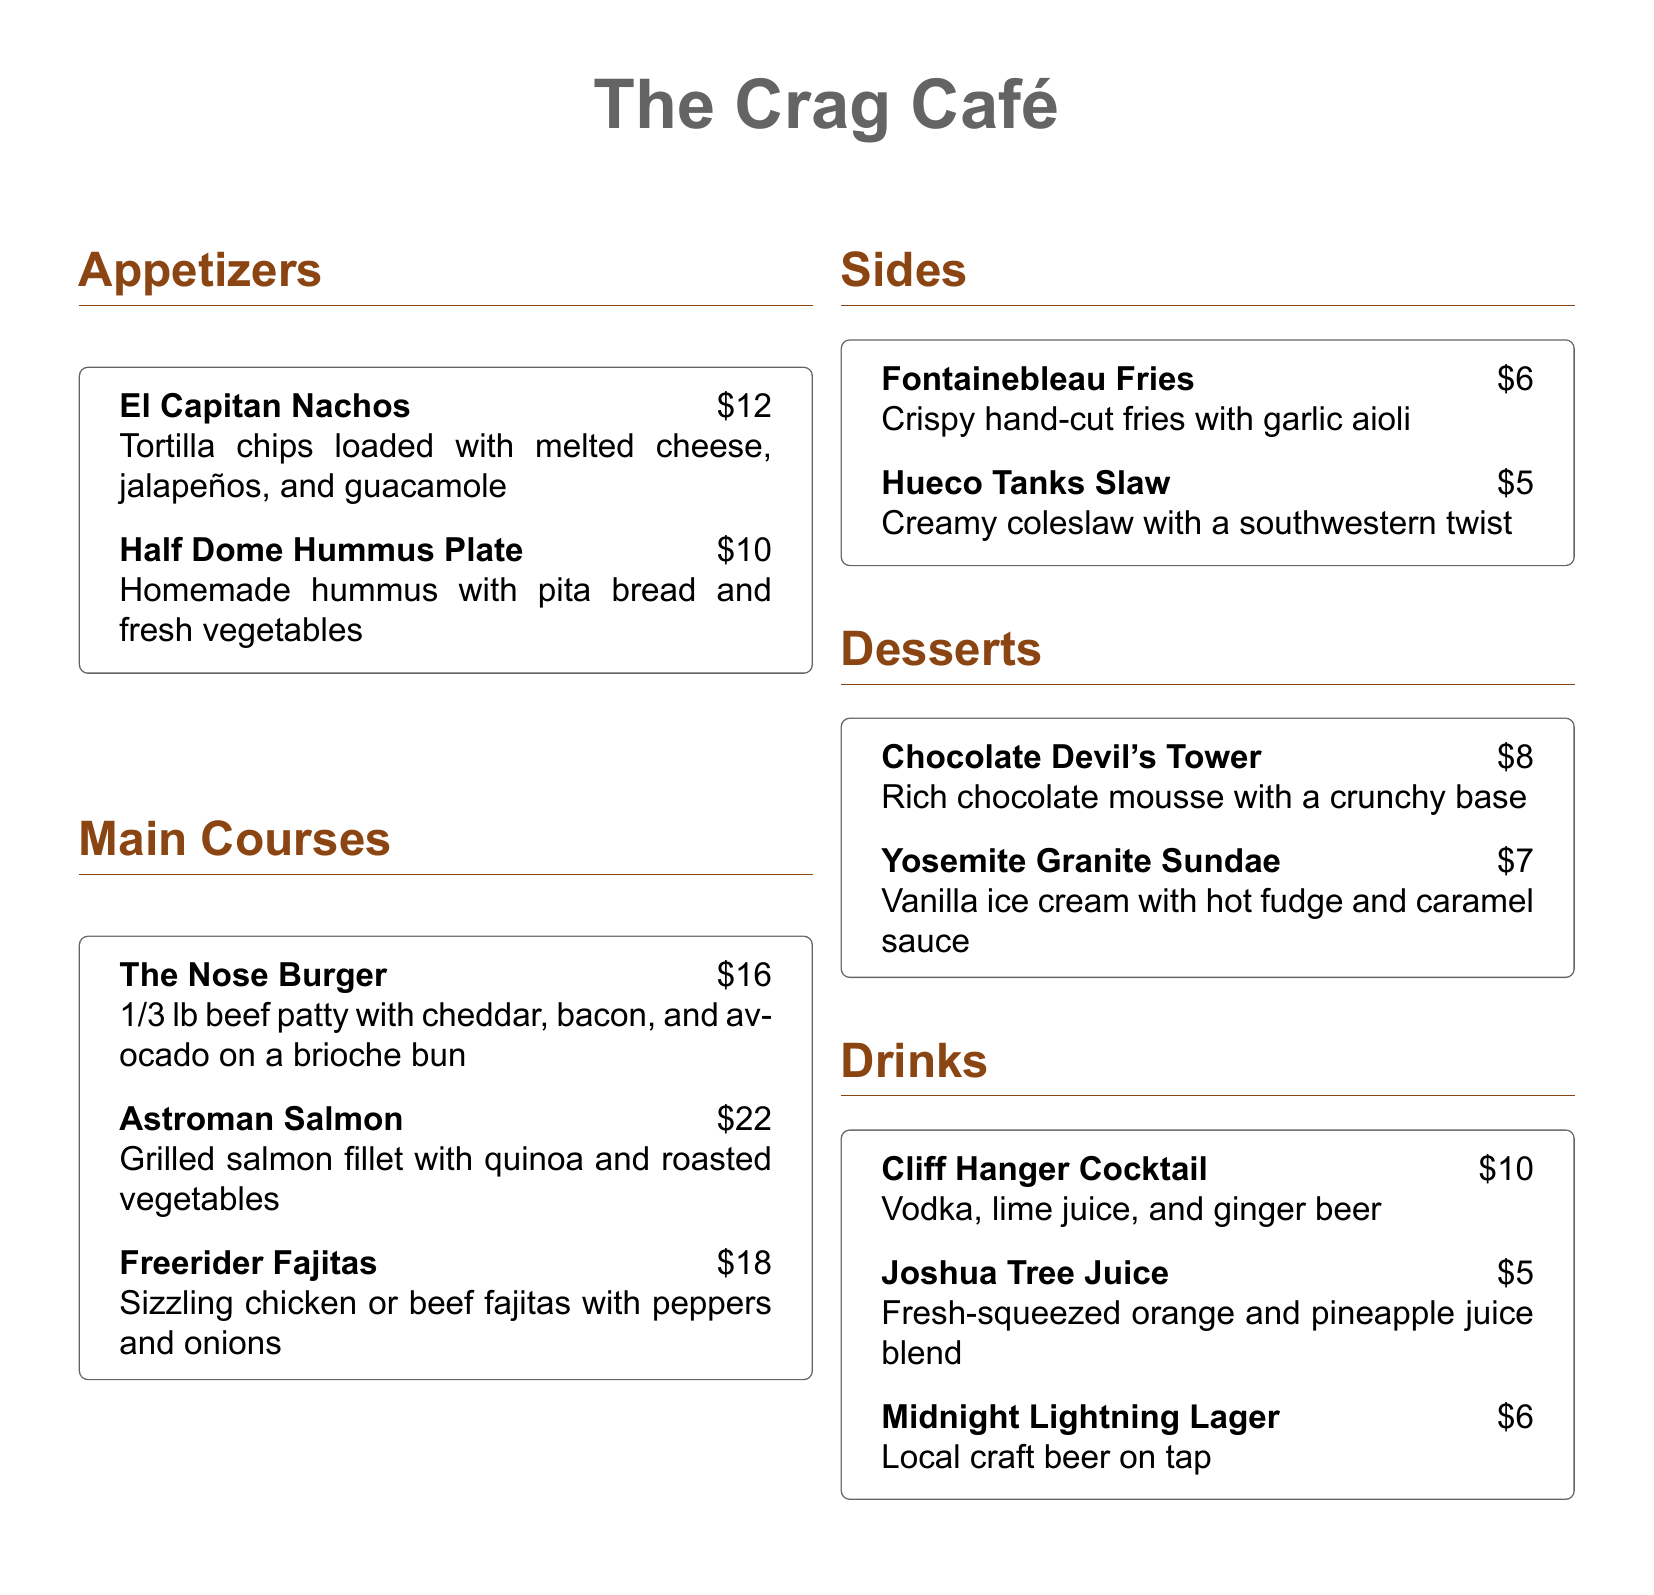What is the most expensive main course? The most expensive main course is listed in the "Main Courses" section of the document, which is "Astroman Salmon" for $22.
Answer: Astroman Salmon How much do the El Capitan Nachos cost? The El Capitan Nachos are listed under Appetizers with a price of $12.
Answer: $12 What is included with the Half Dome Hummus Plate? The Half Dome Hummus Plate contains homemade hummus with pita bread and fresh vegetables.
Answer: Hummus, pita bread, fresh vegetables Which drink contains ginger beer? The drink named "Cliff Hanger Cocktail" includes vodka, lime juice, and ginger beer.
Answer: Cliff Hanger Cocktail How many appetizers are listed? There are two appetizers listed in the "Appetizers" section of the menu.
Answer: Two What side dish costs $5? The side dish listed for $5 is "Hueco Tanks Slaw."
Answer: Hueco Tanks Slaw What type of dessert is Chocolate Devil's Tower? Chocolate Devil's Tower is described as rich chocolate mousse with a crunchy base, indicating it is a mousse dessert.
Answer: Mousse Which main course is related to a rock formation known as "The Nose"? The main course associated with "The Nose" is called "The Nose Burger."
Answer: The Nose Burger 